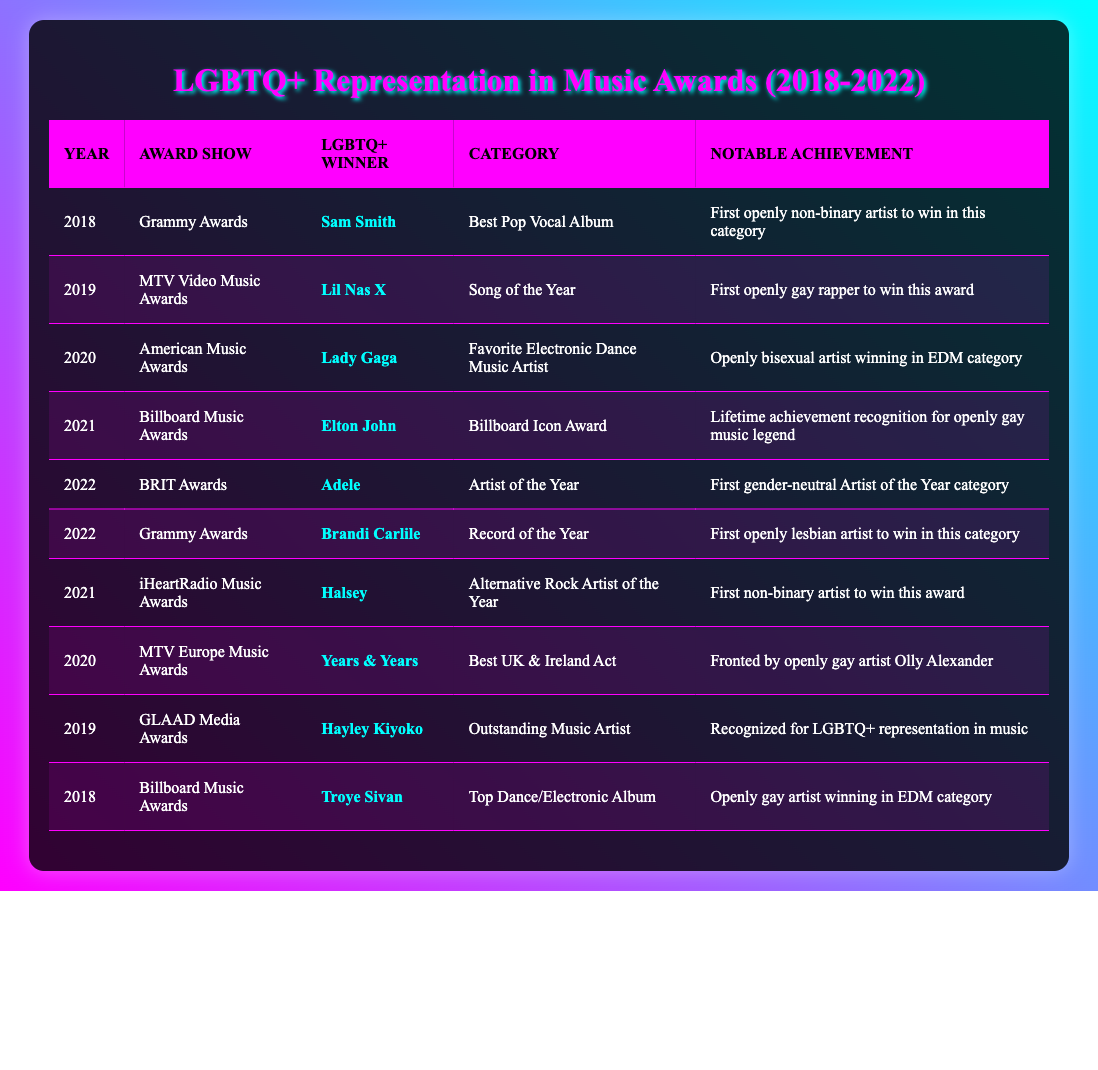What artist won the Best Pop Vocal Album at the Grammy Awards in 2018? In the table, under the "Year" column, find the entry for 2018 and look in the same row for the "Award Show" column with the value "Grammy Awards". The corresponding value in the "LGBTQ+ Winner" column is "Sam Smith".
Answer: Sam Smith How many LGBTQ+ artists won awards in 2021? Looking at the table, there are two entries for the year 2021. They are Elton John and Halsey, both of whom are LGBTQ+ artists, so the total count of LGBTQ+ winners in 2021 is 2.
Answer: 2 Did Lil Nas X win a music award in 2019? Referring to the table, check the row where the year is 2019 and confirm whether Lil Nas X, listed as the LGBTQ+ Winner, is recognized for an award. The entry shows he won "Song of the Year" at the "MTV Video Music Awards".
Answer: Yes Which artist achieved a notable recognition related to gender-neutral categories at the 2022 BRIT Awards? Going through the table, we check the year 2022 and find the award show "BRIT Awards" has Adele as the winner. The notable achievement states it was the "First gender-neutral Artist of the Year category", confirming the recognition.
Answer: Adele What was the significant achievement of Lady Gaga at the American Music Awards in 2020? Review the entry for the year 2020 in the table. Lady Gaga won "Favorite Electronic Dance Music Artist", and the notable achievement describes her as an "Openly bisexual artist winning in EDM category". This details her significant achievement.
Answer: Openly bisexual artist winning in EDM category How many LGBTQ+ artists won awards in the EDM category from 2018 to 2022? In the table, identify the rows under the "Category" column that mention EDM. From what I find, those entries are under Lady Gaga in 2020 and Troye Sivan in 2018, giving a total count of 2 LGBTQ+ artists who won in this category during this period.
Answer: 2 Was Hayley Kiyoko recognized for her contributions to LGBTQ+ representation in the music industry? The row for Hayley Kiyoko in 2019 at the "GLAAD Media Awards" shows her as the winner of "Outstanding Music Artist", with the notable achievement stating her recognition for LGBTQ+ representation in music.
Answer: Yes Among the listed winners from 2018 to 2022, who has the notable achievement related to being the first openly lesbian artist to win Record of the Year? Focusing on the Grammy Awards for the year 2022, the entry for Brandi Carlile indicates that she is the "first openly lesbian artist to win in this category" and thus meets the criteria defined.
Answer: Brandi Carlile 